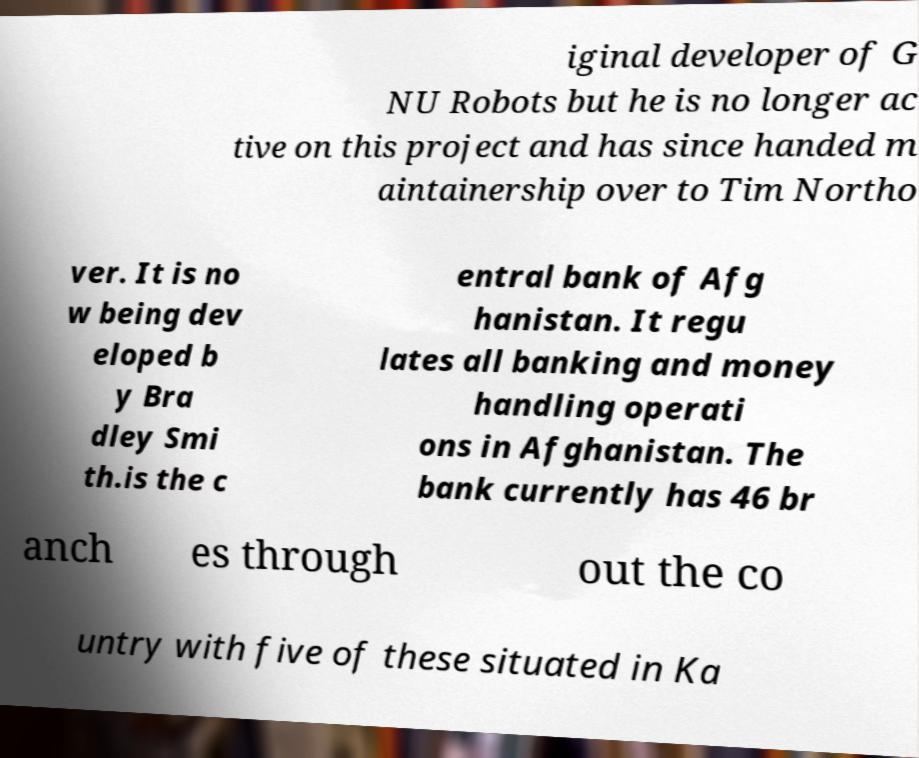There's text embedded in this image that I need extracted. Can you transcribe it verbatim? iginal developer of G NU Robots but he is no longer ac tive on this project and has since handed m aintainership over to Tim Northo ver. It is no w being dev eloped b y Bra dley Smi th.is the c entral bank of Afg hanistan. It regu lates all banking and money handling operati ons in Afghanistan. The bank currently has 46 br anch es through out the co untry with five of these situated in Ka 